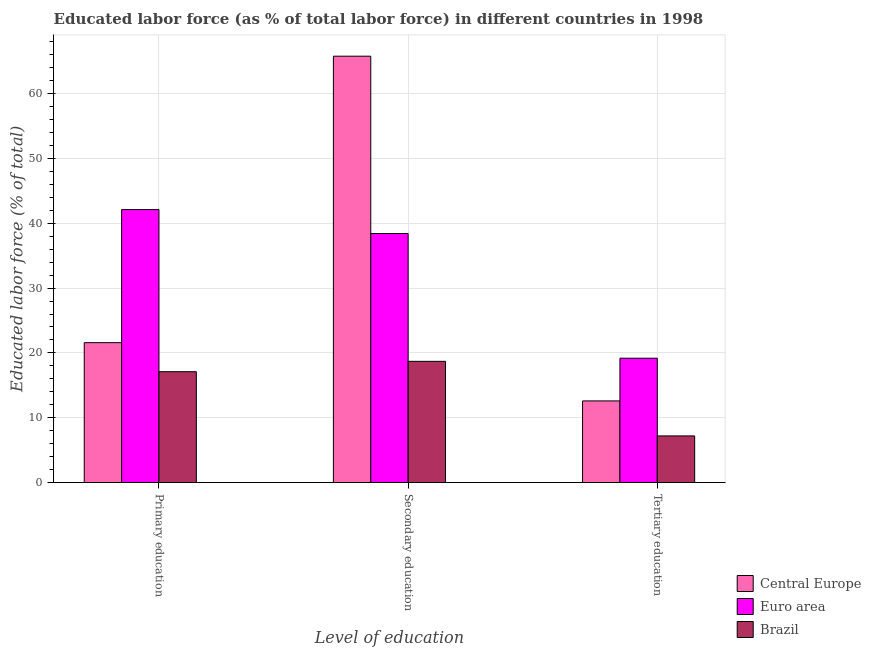How many different coloured bars are there?
Keep it short and to the point. 3. What is the label of the 3rd group of bars from the left?
Keep it short and to the point. Tertiary education. What is the percentage of labor force who received primary education in Brazil?
Give a very brief answer. 17.1. Across all countries, what is the maximum percentage of labor force who received primary education?
Offer a terse response. 42.1. Across all countries, what is the minimum percentage of labor force who received tertiary education?
Give a very brief answer. 7.2. In which country was the percentage of labor force who received secondary education maximum?
Keep it short and to the point. Central Europe. In which country was the percentage of labor force who received tertiary education minimum?
Your response must be concise. Brazil. What is the total percentage of labor force who received primary education in the graph?
Offer a very short reply. 80.78. What is the difference between the percentage of labor force who received secondary education in Central Europe and that in Brazil?
Give a very brief answer. 47.06. What is the difference between the percentage of labor force who received primary education in Euro area and the percentage of labor force who received tertiary education in Brazil?
Offer a terse response. 34.9. What is the average percentage of labor force who received tertiary education per country?
Your response must be concise. 12.99. What is the difference between the percentage of labor force who received tertiary education and percentage of labor force who received primary education in Central Europe?
Your answer should be compact. -8.98. What is the ratio of the percentage of labor force who received tertiary education in Central Europe to that in Brazil?
Your answer should be compact. 1.75. Is the percentage of labor force who received primary education in Brazil less than that in Euro area?
Your answer should be very brief. Yes. What is the difference between the highest and the second highest percentage of labor force who received tertiary education?
Your response must be concise. 6.58. What is the difference between the highest and the lowest percentage of labor force who received secondary education?
Offer a very short reply. 47.06. In how many countries, is the percentage of labor force who received primary education greater than the average percentage of labor force who received primary education taken over all countries?
Keep it short and to the point. 1. Is the sum of the percentage of labor force who received tertiary education in Brazil and Euro area greater than the maximum percentage of labor force who received secondary education across all countries?
Offer a terse response. No. What does the 1st bar from the left in Secondary education represents?
Your answer should be very brief. Central Europe. Are all the bars in the graph horizontal?
Provide a short and direct response. No. What is the difference between two consecutive major ticks on the Y-axis?
Your response must be concise. 10. Are the values on the major ticks of Y-axis written in scientific E-notation?
Your answer should be compact. No. Does the graph contain any zero values?
Provide a short and direct response. No. Does the graph contain grids?
Your answer should be very brief. Yes. How many legend labels are there?
Ensure brevity in your answer.  3. What is the title of the graph?
Provide a short and direct response. Educated labor force (as % of total labor force) in different countries in 1998. Does "Bhutan" appear as one of the legend labels in the graph?
Your answer should be very brief. No. What is the label or title of the X-axis?
Ensure brevity in your answer.  Level of education. What is the label or title of the Y-axis?
Your answer should be very brief. Educated labor force (% of total). What is the Educated labor force (% of total) in Central Europe in Primary education?
Your answer should be compact. 21.58. What is the Educated labor force (% of total) of Euro area in Primary education?
Make the answer very short. 42.1. What is the Educated labor force (% of total) of Brazil in Primary education?
Give a very brief answer. 17.1. What is the Educated labor force (% of total) in Central Europe in Secondary education?
Make the answer very short. 65.76. What is the Educated labor force (% of total) of Euro area in Secondary education?
Offer a very short reply. 38.41. What is the Educated labor force (% of total) in Brazil in Secondary education?
Provide a short and direct response. 18.7. What is the Educated labor force (% of total) in Central Europe in Tertiary education?
Give a very brief answer. 12.6. What is the Educated labor force (% of total) of Euro area in Tertiary education?
Offer a terse response. 19.18. What is the Educated labor force (% of total) in Brazil in Tertiary education?
Give a very brief answer. 7.2. Across all Level of education, what is the maximum Educated labor force (% of total) in Central Europe?
Ensure brevity in your answer.  65.76. Across all Level of education, what is the maximum Educated labor force (% of total) of Euro area?
Your answer should be compact. 42.1. Across all Level of education, what is the maximum Educated labor force (% of total) in Brazil?
Offer a very short reply. 18.7. Across all Level of education, what is the minimum Educated labor force (% of total) of Central Europe?
Your response must be concise. 12.6. Across all Level of education, what is the minimum Educated labor force (% of total) of Euro area?
Keep it short and to the point. 19.18. Across all Level of education, what is the minimum Educated labor force (% of total) in Brazil?
Your answer should be very brief. 7.2. What is the total Educated labor force (% of total) in Central Europe in the graph?
Your answer should be very brief. 99.93. What is the total Educated labor force (% of total) of Euro area in the graph?
Your response must be concise. 99.69. What is the total Educated labor force (% of total) of Brazil in the graph?
Your response must be concise. 43. What is the difference between the Educated labor force (% of total) in Central Europe in Primary education and that in Secondary education?
Your answer should be very brief. -44.18. What is the difference between the Educated labor force (% of total) in Euro area in Primary education and that in Secondary education?
Offer a very short reply. 3.7. What is the difference between the Educated labor force (% of total) in Central Europe in Primary education and that in Tertiary education?
Provide a short and direct response. 8.98. What is the difference between the Educated labor force (% of total) in Euro area in Primary education and that in Tertiary education?
Ensure brevity in your answer.  22.92. What is the difference between the Educated labor force (% of total) of Central Europe in Secondary education and that in Tertiary education?
Give a very brief answer. 53.16. What is the difference between the Educated labor force (% of total) in Euro area in Secondary education and that in Tertiary education?
Provide a short and direct response. 19.22. What is the difference between the Educated labor force (% of total) of Central Europe in Primary education and the Educated labor force (% of total) of Euro area in Secondary education?
Your answer should be compact. -16.83. What is the difference between the Educated labor force (% of total) of Central Europe in Primary education and the Educated labor force (% of total) of Brazil in Secondary education?
Your answer should be compact. 2.88. What is the difference between the Educated labor force (% of total) in Euro area in Primary education and the Educated labor force (% of total) in Brazil in Secondary education?
Provide a succinct answer. 23.4. What is the difference between the Educated labor force (% of total) in Central Europe in Primary education and the Educated labor force (% of total) in Euro area in Tertiary education?
Provide a short and direct response. 2.4. What is the difference between the Educated labor force (% of total) of Central Europe in Primary education and the Educated labor force (% of total) of Brazil in Tertiary education?
Make the answer very short. 14.38. What is the difference between the Educated labor force (% of total) of Euro area in Primary education and the Educated labor force (% of total) of Brazil in Tertiary education?
Offer a terse response. 34.9. What is the difference between the Educated labor force (% of total) of Central Europe in Secondary education and the Educated labor force (% of total) of Euro area in Tertiary education?
Make the answer very short. 46.57. What is the difference between the Educated labor force (% of total) of Central Europe in Secondary education and the Educated labor force (% of total) of Brazil in Tertiary education?
Provide a short and direct response. 58.56. What is the difference between the Educated labor force (% of total) of Euro area in Secondary education and the Educated labor force (% of total) of Brazil in Tertiary education?
Offer a terse response. 31.21. What is the average Educated labor force (% of total) in Central Europe per Level of education?
Offer a terse response. 33.31. What is the average Educated labor force (% of total) in Euro area per Level of education?
Give a very brief answer. 33.23. What is the average Educated labor force (% of total) of Brazil per Level of education?
Your answer should be compact. 14.33. What is the difference between the Educated labor force (% of total) of Central Europe and Educated labor force (% of total) of Euro area in Primary education?
Give a very brief answer. -20.52. What is the difference between the Educated labor force (% of total) in Central Europe and Educated labor force (% of total) in Brazil in Primary education?
Offer a terse response. 4.48. What is the difference between the Educated labor force (% of total) of Euro area and Educated labor force (% of total) of Brazil in Primary education?
Make the answer very short. 25. What is the difference between the Educated labor force (% of total) in Central Europe and Educated labor force (% of total) in Euro area in Secondary education?
Your answer should be compact. 27.35. What is the difference between the Educated labor force (% of total) in Central Europe and Educated labor force (% of total) in Brazil in Secondary education?
Provide a short and direct response. 47.06. What is the difference between the Educated labor force (% of total) of Euro area and Educated labor force (% of total) of Brazil in Secondary education?
Ensure brevity in your answer.  19.71. What is the difference between the Educated labor force (% of total) in Central Europe and Educated labor force (% of total) in Euro area in Tertiary education?
Offer a very short reply. -6.58. What is the difference between the Educated labor force (% of total) in Central Europe and Educated labor force (% of total) in Brazil in Tertiary education?
Provide a succinct answer. 5.4. What is the difference between the Educated labor force (% of total) of Euro area and Educated labor force (% of total) of Brazil in Tertiary education?
Your response must be concise. 11.98. What is the ratio of the Educated labor force (% of total) of Central Europe in Primary education to that in Secondary education?
Your response must be concise. 0.33. What is the ratio of the Educated labor force (% of total) in Euro area in Primary education to that in Secondary education?
Your answer should be very brief. 1.1. What is the ratio of the Educated labor force (% of total) in Brazil in Primary education to that in Secondary education?
Your answer should be very brief. 0.91. What is the ratio of the Educated labor force (% of total) in Central Europe in Primary education to that in Tertiary education?
Your answer should be very brief. 1.71. What is the ratio of the Educated labor force (% of total) of Euro area in Primary education to that in Tertiary education?
Offer a very short reply. 2.19. What is the ratio of the Educated labor force (% of total) of Brazil in Primary education to that in Tertiary education?
Your answer should be very brief. 2.38. What is the ratio of the Educated labor force (% of total) of Central Europe in Secondary education to that in Tertiary education?
Make the answer very short. 5.22. What is the ratio of the Educated labor force (% of total) of Euro area in Secondary education to that in Tertiary education?
Ensure brevity in your answer.  2. What is the ratio of the Educated labor force (% of total) of Brazil in Secondary education to that in Tertiary education?
Make the answer very short. 2.6. What is the difference between the highest and the second highest Educated labor force (% of total) in Central Europe?
Provide a short and direct response. 44.18. What is the difference between the highest and the second highest Educated labor force (% of total) in Euro area?
Your response must be concise. 3.7. What is the difference between the highest and the second highest Educated labor force (% of total) in Brazil?
Your response must be concise. 1.6. What is the difference between the highest and the lowest Educated labor force (% of total) in Central Europe?
Give a very brief answer. 53.16. What is the difference between the highest and the lowest Educated labor force (% of total) in Euro area?
Your response must be concise. 22.92. What is the difference between the highest and the lowest Educated labor force (% of total) of Brazil?
Your answer should be compact. 11.5. 